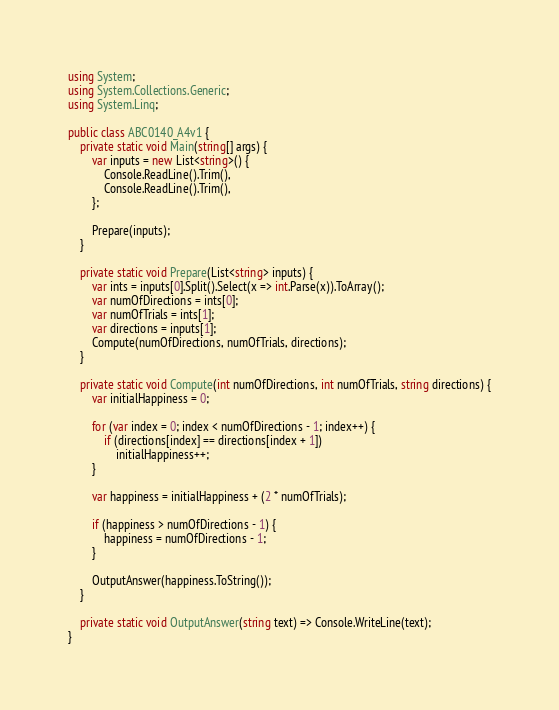Convert code to text. <code><loc_0><loc_0><loc_500><loc_500><_C#_>using System;
using System.Collections.Generic;
using System.Linq;

public class ABC0140_A4v1 {
    private static void Main(string[] args) {
        var inputs = new List<string>() {
            Console.ReadLine().Trim(),
            Console.ReadLine().Trim(),
        };

        Prepare(inputs);
    }

    private static void Prepare(List<string> inputs) {
        var ints = inputs[0].Split().Select(x => int.Parse(x)).ToArray();
        var numOfDirections = ints[0];
        var numOfTrials = ints[1];
        var directions = inputs[1];
        Compute(numOfDirections, numOfTrials, directions);
    }

    private static void Compute(int numOfDirections, int numOfTrials, string directions) {
        var initialHappiness = 0;

        for (var index = 0; index < numOfDirections - 1; index++) {
            if (directions[index] == directions[index + 1])
                initialHappiness++;
        }

        var happiness = initialHappiness + (2 * numOfTrials);
      
        if (happiness > numOfDirections - 1) {
            happiness = numOfDirections - 1;
        }

        OutputAnswer(happiness.ToString());
    }

    private static void OutputAnswer(string text) => Console.WriteLine(text);
}
</code> 